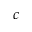Convert formula to latex. <formula><loc_0><loc_0><loc_500><loc_500>c</formula> 